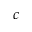Convert formula to latex. <formula><loc_0><loc_0><loc_500><loc_500>c</formula> 